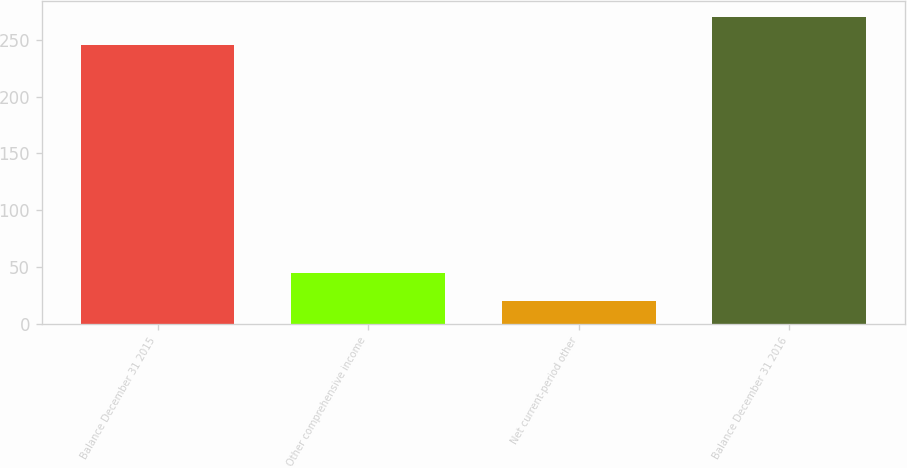<chart> <loc_0><loc_0><loc_500><loc_500><bar_chart><fcel>Balance December 31 2015<fcel>Other comprehensive income<fcel>Net current-period other<fcel>Balance December 31 2016<nl><fcel>245.8<fcel>44.68<fcel>20.1<fcel>270.38<nl></chart> 